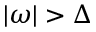Convert formula to latex. <formula><loc_0><loc_0><loc_500><loc_500>| \omega | > \Delta</formula> 